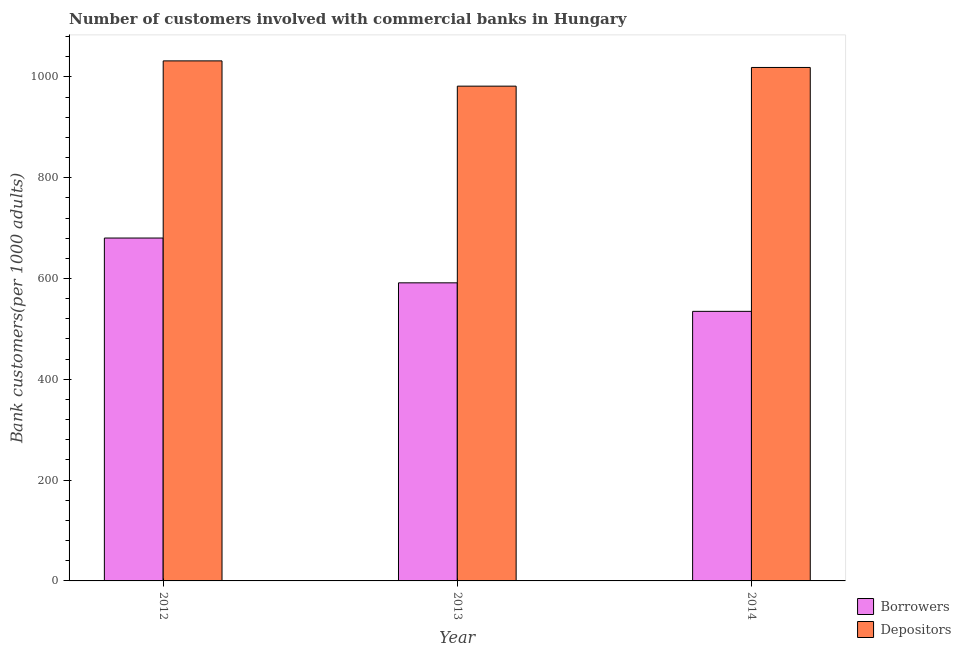How many different coloured bars are there?
Provide a succinct answer. 2. How many groups of bars are there?
Keep it short and to the point. 3. How many bars are there on the 3rd tick from the left?
Provide a succinct answer. 2. How many bars are there on the 3rd tick from the right?
Ensure brevity in your answer.  2. In how many cases, is the number of bars for a given year not equal to the number of legend labels?
Make the answer very short. 0. What is the number of borrowers in 2014?
Your answer should be very brief. 534.85. Across all years, what is the maximum number of borrowers?
Keep it short and to the point. 680.32. Across all years, what is the minimum number of depositors?
Keep it short and to the point. 981.67. In which year was the number of borrowers maximum?
Make the answer very short. 2012. What is the total number of depositors in the graph?
Your answer should be compact. 3032.23. What is the difference between the number of borrowers in 2013 and that in 2014?
Keep it short and to the point. 56.56. What is the difference between the number of depositors in 2012 and the number of borrowers in 2014?
Your response must be concise. 13.07. What is the average number of depositors per year?
Offer a very short reply. 1010.74. In the year 2012, what is the difference between the number of depositors and number of borrowers?
Give a very brief answer. 0. What is the ratio of the number of depositors in 2012 to that in 2013?
Provide a succinct answer. 1.05. Is the number of depositors in 2013 less than that in 2014?
Offer a terse response. Yes. What is the difference between the highest and the second highest number of borrowers?
Your answer should be compact. 88.9. What is the difference between the highest and the lowest number of depositors?
Offer a very short reply. 50.15. In how many years, is the number of borrowers greater than the average number of borrowers taken over all years?
Your response must be concise. 1. Is the sum of the number of depositors in 2012 and 2014 greater than the maximum number of borrowers across all years?
Your response must be concise. Yes. What does the 2nd bar from the left in 2014 represents?
Make the answer very short. Depositors. What does the 2nd bar from the right in 2013 represents?
Your response must be concise. Borrowers. How many bars are there?
Your answer should be very brief. 6. Are all the bars in the graph horizontal?
Offer a very short reply. No. What is the difference between two consecutive major ticks on the Y-axis?
Your answer should be compact. 200. Are the values on the major ticks of Y-axis written in scientific E-notation?
Make the answer very short. No. Does the graph contain any zero values?
Your answer should be compact. No. Where does the legend appear in the graph?
Provide a short and direct response. Bottom right. How many legend labels are there?
Give a very brief answer. 2. What is the title of the graph?
Make the answer very short. Number of customers involved with commercial banks in Hungary. What is the label or title of the Y-axis?
Offer a terse response. Bank customers(per 1000 adults). What is the Bank customers(per 1000 adults) of Borrowers in 2012?
Make the answer very short. 680.32. What is the Bank customers(per 1000 adults) in Depositors in 2012?
Provide a succinct answer. 1031.82. What is the Bank customers(per 1000 adults) in Borrowers in 2013?
Ensure brevity in your answer.  591.42. What is the Bank customers(per 1000 adults) in Depositors in 2013?
Ensure brevity in your answer.  981.67. What is the Bank customers(per 1000 adults) in Borrowers in 2014?
Provide a short and direct response. 534.85. What is the Bank customers(per 1000 adults) of Depositors in 2014?
Your answer should be very brief. 1018.74. Across all years, what is the maximum Bank customers(per 1000 adults) of Borrowers?
Your answer should be compact. 680.32. Across all years, what is the maximum Bank customers(per 1000 adults) of Depositors?
Make the answer very short. 1031.82. Across all years, what is the minimum Bank customers(per 1000 adults) in Borrowers?
Offer a very short reply. 534.85. Across all years, what is the minimum Bank customers(per 1000 adults) of Depositors?
Your answer should be compact. 981.67. What is the total Bank customers(per 1000 adults) of Borrowers in the graph?
Keep it short and to the point. 1806.59. What is the total Bank customers(per 1000 adults) of Depositors in the graph?
Your answer should be compact. 3032.23. What is the difference between the Bank customers(per 1000 adults) of Borrowers in 2012 and that in 2013?
Your response must be concise. 88.9. What is the difference between the Bank customers(per 1000 adults) of Depositors in 2012 and that in 2013?
Offer a very short reply. 50.15. What is the difference between the Bank customers(per 1000 adults) of Borrowers in 2012 and that in 2014?
Provide a short and direct response. 145.46. What is the difference between the Bank customers(per 1000 adults) of Depositors in 2012 and that in 2014?
Your answer should be very brief. 13.07. What is the difference between the Bank customers(per 1000 adults) of Borrowers in 2013 and that in 2014?
Give a very brief answer. 56.56. What is the difference between the Bank customers(per 1000 adults) of Depositors in 2013 and that in 2014?
Your answer should be very brief. -37.07. What is the difference between the Bank customers(per 1000 adults) of Borrowers in 2012 and the Bank customers(per 1000 adults) of Depositors in 2013?
Keep it short and to the point. -301.35. What is the difference between the Bank customers(per 1000 adults) in Borrowers in 2012 and the Bank customers(per 1000 adults) in Depositors in 2014?
Keep it short and to the point. -338.42. What is the difference between the Bank customers(per 1000 adults) in Borrowers in 2013 and the Bank customers(per 1000 adults) in Depositors in 2014?
Provide a succinct answer. -427.33. What is the average Bank customers(per 1000 adults) in Borrowers per year?
Your answer should be very brief. 602.2. What is the average Bank customers(per 1000 adults) in Depositors per year?
Make the answer very short. 1010.74. In the year 2012, what is the difference between the Bank customers(per 1000 adults) of Borrowers and Bank customers(per 1000 adults) of Depositors?
Keep it short and to the point. -351.5. In the year 2013, what is the difference between the Bank customers(per 1000 adults) of Borrowers and Bank customers(per 1000 adults) of Depositors?
Your answer should be compact. -390.25. In the year 2014, what is the difference between the Bank customers(per 1000 adults) in Borrowers and Bank customers(per 1000 adults) in Depositors?
Offer a terse response. -483.89. What is the ratio of the Bank customers(per 1000 adults) of Borrowers in 2012 to that in 2013?
Offer a very short reply. 1.15. What is the ratio of the Bank customers(per 1000 adults) in Depositors in 2012 to that in 2013?
Provide a succinct answer. 1.05. What is the ratio of the Bank customers(per 1000 adults) in Borrowers in 2012 to that in 2014?
Make the answer very short. 1.27. What is the ratio of the Bank customers(per 1000 adults) in Depositors in 2012 to that in 2014?
Keep it short and to the point. 1.01. What is the ratio of the Bank customers(per 1000 adults) in Borrowers in 2013 to that in 2014?
Provide a short and direct response. 1.11. What is the ratio of the Bank customers(per 1000 adults) in Depositors in 2013 to that in 2014?
Make the answer very short. 0.96. What is the difference between the highest and the second highest Bank customers(per 1000 adults) of Borrowers?
Ensure brevity in your answer.  88.9. What is the difference between the highest and the second highest Bank customers(per 1000 adults) of Depositors?
Offer a very short reply. 13.07. What is the difference between the highest and the lowest Bank customers(per 1000 adults) in Borrowers?
Keep it short and to the point. 145.46. What is the difference between the highest and the lowest Bank customers(per 1000 adults) in Depositors?
Make the answer very short. 50.15. 